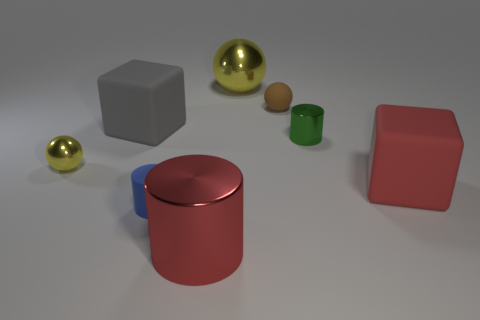Are there more green shiny cylinders left of the gray rubber cube than tiny blue cylinders that are behind the big red cube?
Keep it short and to the point. No. What number of spheres are either big objects or small green metallic things?
Keep it short and to the point. 1. Does the yellow object to the right of the big red metal object have the same shape as the small green metal object?
Provide a succinct answer. No. The big shiny sphere has what color?
Provide a succinct answer. Yellow. There is another big matte object that is the same shape as the red matte thing; what color is it?
Provide a succinct answer. Gray. How many tiny blue objects are the same shape as the tiny green shiny thing?
Your answer should be very brief. 1. What number of things are gray things or small blue rubber cylinders that are left of the large red cylinder?
Offer a very short reply. 2. There is a rubber cylinder; is it the same color as the big matte thing that is left of the red metal object?
Give a very brief answer. No. How big is the cylinder that is on the left side of the big metal sphere and behind the big red shiny cylinder?
Offer a very short reply. Small. Are there any small spheres behind the gray matte cube?
Ensure brevity in your answer.  Yes. 